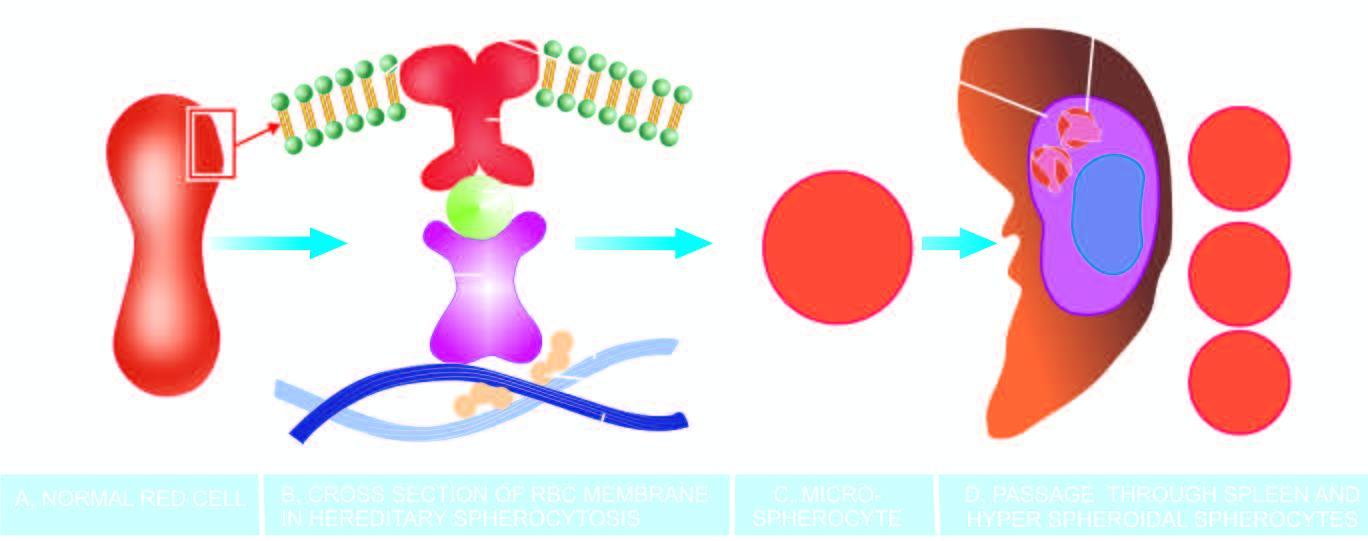what results in spherical contour and small size so as to contain the given volume of haemoglobin in the deformed red cell?
Answer the question using a single word or phrase. This 